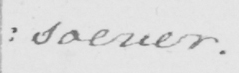What is written in this line of handwriting? : soever . 